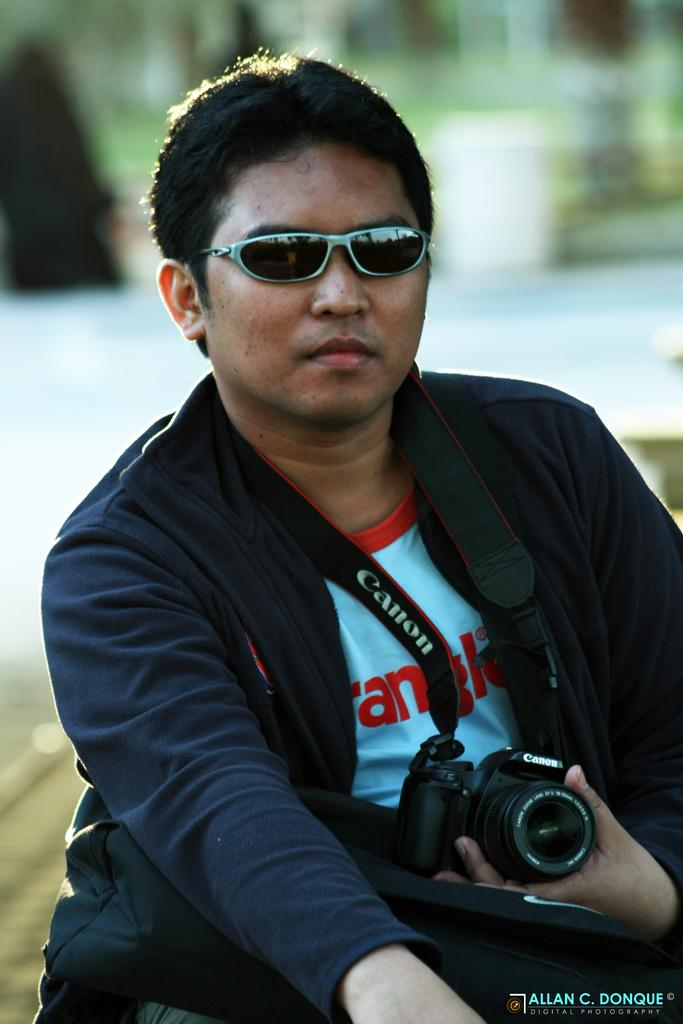Who is present in the image? There is a person in the image. What is the person wearing? The person is wearing a black jacket. What type of eyewear is the person wearing? The person is wearing goggles. What is the person holding in their hands? The person is holding a camera in their hands. What type of bread is the person eating in the image? There is no bread present in the image; the person is holding a camera. 